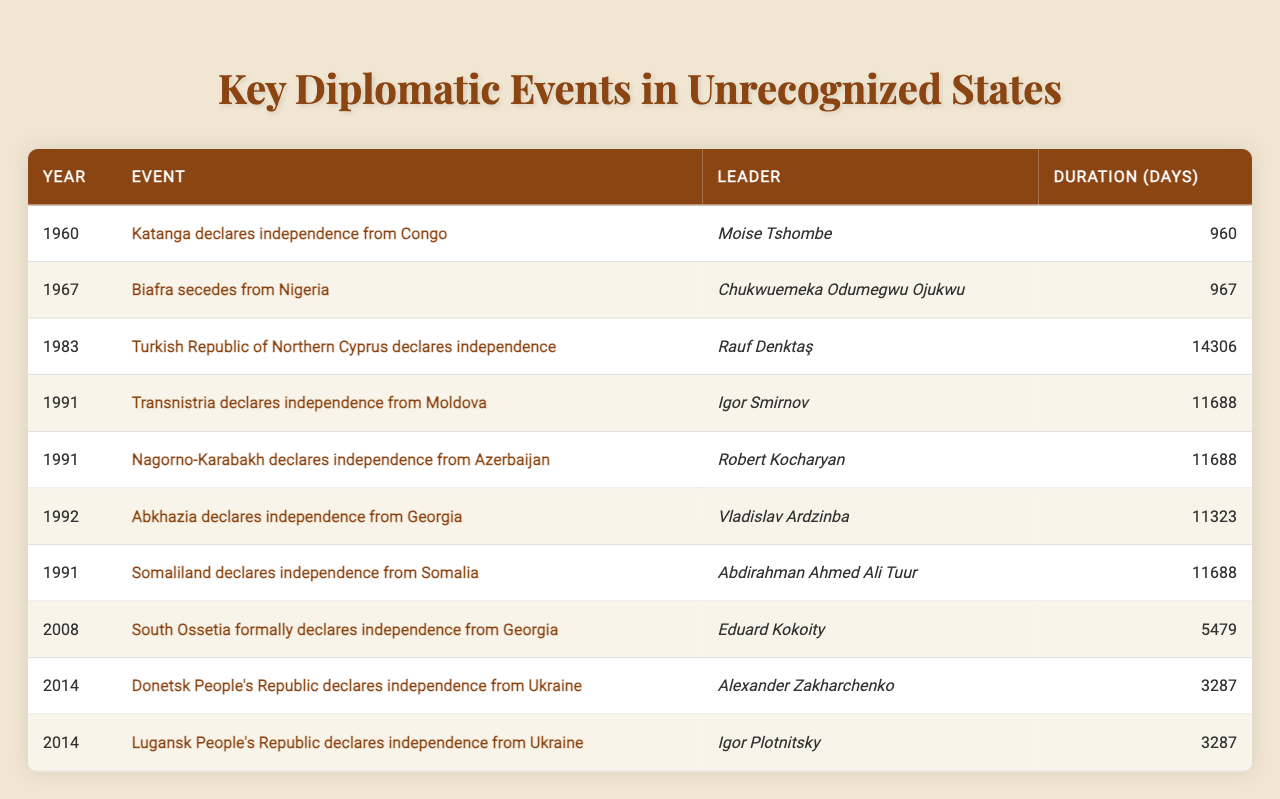What year did Biafra declare independence? The table lists the event "Biafra secedes from Nigeria" and shows the year as 1967.
Answer: 1967 Who was the leader of the Turkish Republic of Northern Cyprus during its declaration of independence? The table indicates that Rauf Denktaş was the leader when the Turkish Republic of Northern Cyprus declared independence in 1983.
Answer: Rauf Denktaş How many days did Katanga's independence last? According to the table, the duration for Katanga's independence is 960 days.
Answer: 960 days Which unrecognized state declared independence in 1991 and has the same duration of independence as Transnistria? The table shows that both Transnistria and Somaliland declared independence in 1991 and both lasted for 11,688 days.
Answer: Somaliland What is the total duration of independence days for the two Ukrainian republics declared in 2014? The table indicates that both the Donetsk People's Republic and Lugansk People's Republic declared independence for 3,287 days each. Thus, the total is 3,287 + 3,287 = 6,574 days.
Answer: 6,574 days In which event did Abkhazia declare independence and who was its leader? The table shows the event "Abkhazia declares independence from Georgia" with Vladislav Ardzinba as its leader in 1992.
Answer: Abkhazia, Vladislav Ardzinba Which declaration of independence lasted the longest, and how many days did it last? The longest duration of independence listed in the table is for the Turkish Republic of Northern Cyprus, lasting 14,306 days.
Answer: 14,306 days Was there any declaration of independence in 2008? The event listed for 2008 is "South Ossetia formally declares independence from Georgia," which confirms that there was a declaration.
Answer: Yes How many events in the table occurred in the year 1991? The table indicates that there are four events listed for the year 1991: Transnistria, Nagorno-Karabakh, and Somaliland.
Answer: Four events What is the difference in duration days between the longest and shortest independence declarations? The longest duration, from the Turkish Republic of Northern Cyprus, is 14,306 days, and the shortest, from Katanga, is 960 days. The difference is 14,306 - 960 = 13,346 days.
Answer: 13,346 days 